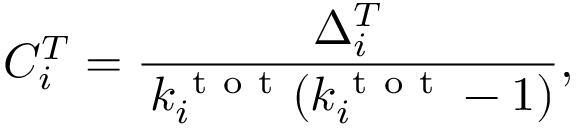Convert formula to latex. <formula><loc_0><loc_0><loc_500><loc_500>C _ { i } ^ { T } = \frac { \Delta _ { i } ^ { T } } { \, k _ { i } ^ { t o t } ( k _ { i } ^ { t o t } - 1 ) } ,</formula> 